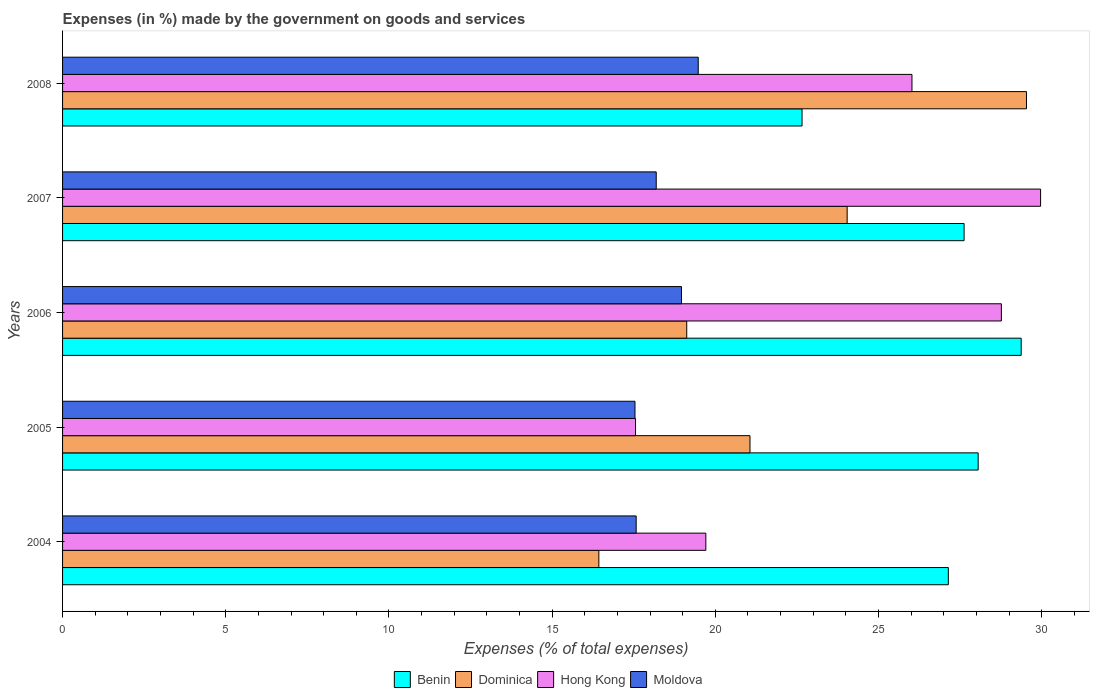How many groups of bars are there?
Keep it short and to the point. 5. Are the number of bars per tick equal to the number of legend labels?
Make the answer very short. Yes. What is the percentage of expenses made by the government on goods and services in Hong Kong in 2007?
Your answer should be compact. 29.97. Across all years, what is the maximum percentage of expenses made by the government on goods and services in Dominica?
Your answer should be compact. 29.53. Across all years, what is the minimum percentage of expenses made by the government on goods and services in Moldova?
Ensure brevity in your answer.  17.54. In which year was the percentage of expenses made by the government on goods and services in Benin minimum?
Keep it short and to the point. 2008. What is the total percentage of expenses made by the government on goods and services in Dominica in the graph?
Offer a very short reply. 110.19. What is the difference between the percentage of expenses made by the government on goods and services in Dominica in 2004 and that in 2005?
Provide a succinct answer. -4.63. What is the difference between the percentage of expenses made by the government on goods and services in Moldova in 2004 and the percentage of expenses made by the government on goods and services in Benin in 2008?
Keep it short and to the point. -5.08. What is the average percentage of expenses made by the government on goods and services in Benin per year?
Keep it short and to the point. 26.97. In the year 2006, what is the difference between the percentage of expenses made by the government on goods and services in Moldova and percentage of expenses made by the government on goods and services in Hong Kong?
Your response must be concise. -9.8. In how many years, is the percentage of expenses made by the government on goods and services in Dominica greater than 15 %?
Your answer should be compact. 5. What is the ratio of the percentage of expenses made by the government on goods and services in Benin in 2006 to that in 2007?
Offer a terse response. 1.06. Is the difference between the percentage of expenses made by the government on goods and services in Moldova in 2005 and 2007 greater than the difference between the percentage of expenses made by the government on goods and services in Hong Kong in 2005 and 2007?
Your response must be concise. Yes. What is the difference between the highest and the second highest percentage of expenses made by the government on goods and services in Benin?
Your answer should be compact. 1.32. What is the difference between the highest and the lowest percentage of expenses made by the government on goods and services in Benin?
Your answer should be very brief. 6.71. In how many years, is the percentage of expenses made by the government on goods and services in Hong Kong greater than the average percentage of expenses made by the government on goods and services in Hong Kong taken over all years?
Provide a short and direct response. 3. What does the 2nd bar from the top in 2007 represents?
Keep it short and to the point. Hong Kong. What does the 3rd bar from the bottom in 2004 represents?
Offer a very short reply. Hong Kong. Are all the bars in the graph horizontal?
Keep it short and to the point. Yes. Are the values on the major ticks of X-axis written in scientific E-notation?
Offer a very short reply. No. Does the graph contain any zero values?
Offer a very short reply. No. How many legend labels are there?
Your answer should be very brief. 4. What is the title of the graph?
Make the answer very short. Expenses (in %) made by the government on goods and services. Does "Bangladesh" appear as one of the legend labels in the graph?
Your answer should be compact. No. What is the label or title of the X-axis?
Keep it short and to the point. Expenses (% of total expenses). What is the Expenses (% of total expenses) of Benin in 2004?
Make the answer very short. 27.14. What is the Expenses (% of total expenses) in Dominica in 2004?
Your response must be concise. 16.43. What is the Expenses (% of total expenses) of Hong Kong in 2004?
Provide a succinct answer. 19.71. What is the Expenses (% of total expenses) of Moldova in 2004?
Your answer should be compact. 17.57. What is the Expenses (% of total expenses) of Benin in 2005?
Offer a very short reply. 28.05. What is the Expenses (% of total expenses) in Dominica in 2005?
Give a very brief answer. 21.06. What is the Expenses (% of total expenses) in Hong Kong in 2005?
Keep it short and to the point. 17.56. What is the Expenses (% of total expenses) in Moldova in 2005?
Make the answer very short. 17.54. What is the Expenses (% of total expenses) of Benin in 2006?
Make the answer very short. 29.37. What is the Expenses (% of total expenses) in Dominica in 2006?
Provide a short and direct response. 19.12. What is the Expenses (% of total expenses) in Hong Kong in 2006?
Provide a succinct answer. 28.76. What is the Expenses (% of total expenses) in Moldova in 2006?
Offer a terse response. 18.96. What is the Expenses (% of total expenses) in Benin in 2007?
Your answer should be compact. 27.62. What is the Expenses (% of total expenses) of Dominica in 2007?
Offer a terse response. 24.04. What is the Expenses (% of total expenses) of Hong Kong in 2007?
Your response must be concise. 29.97. What is the Expenses (% of total expenses) of Moldova in 2007?
Ensure brevity in your answer.  18.19. What is the Expenses (% of total expenses) of Benin in 2008?
Offer a very short reply. 22.66. What is the Expenses (% of total expenses) in Dominica in 2008?
Your answer should be compact. 29.53. What is the Expenses (% of total expenses) in Hong Kong in 2008?
Make the answer very short. 26.02. What is the Expenses (% of total expenses) of Moldova in 2008?
Offer a very short reply. 19.48. Across all years, what is the maximum Expenses (% of total expenses) of Benin?
Offer a terse response. 29.37. Across all years, what is the maximum Expenses (% of total expenses) of Dominica?
Offer a terse response. 29.53. Across all years, what is the maximum Expenses (% of total expenses) of Hong Kong?
Keep it short and to the point. 29.97. Across all years, what is the maximum Expenses (% of total expenses) in Moldova?
Keep it short and to the point. 19.48. Across all years, what is the minimum Expenses (% of total expenses) in Benin?
Offer a terse response. 22.66. Across all years, what is the minimum Expenses (% of total expenses) in Dominica?
Offer a terse response. 16.43. Across all years, what is the minimum Expenses (% of total expenses) of Hong Kong?
Ensure brevity in your answer.  17.56. Across all years, what is the minimum Expenses (% of total expenses) of Moldova?
Your answer should be very brief. 17.54. What is the total Expenses (% of total expenses) of Benin in the graph?
Your response must be concise. 134.84. What is the total Expenses (% of total expenses) of Dominica in the graph?
Give a very brief answer. 110.19. What is the total Expenses (% of total expenses) of Hong Kong in the graph?
Keep it short and to the point. 122.02. What is the total Expenses (% of total expenses) in Moldova in the graph?
Make the answer very short. 91.74. What is the difference between the Expenses (% of total expenses) of Benin in 2004 and that in 2005?
Your answer should be compact. -0.91. What is the difference between the Expenses (% of total expenses) of Dominica in 2004 and that in 2005?
Give a very brief answer. -4.63. What is the difference between the Expenses (% of total expenses) of Hong Kong in 2004 and that in 2005?
Your answer should be very brief. 2.15. What is the difference between the Expenses (% of total expenses) in Moldova in 2004 and that in 2005?
Ensure brevity in your answer.  0.04. What is the difference between the Expenses (% of total expenses) in Benin in 2004 and that in 2006?
Your answer should be compact. -2.23. What is the difference between the Expenses (% of total expenses) of Dominica in 2004 and that in 2006?
Make the answer very short. -2.69. What is the difference between the Expenses (% of total expenses) of Hong Kong in 2004 and that in 2006?
Your response must be concise. -9.05. What is the difference between the Expenses (% of total expenses) in Moldova in 2004 and that in 2006?
Provide a short and direct response. -1.39. What is the difference between the Expenses (% of total expenses) of Benin in 2004 and that in 2007?
Give a very brief answer. -0.48. What is the difference between the Expenses (% of total expenses) of Dominica in 2004 and that in 2007?
Offer a terse response. -7.61. What is the difference between the Expenses (% of total expenses) in Hong Kong in 2004 and that in 2007?
Your answer should be very brief. -10.26. What is the difference between the Expenses (% of total expenses) of Moldova in 2004 and that in 2007?
Your answer should be compact. -0.61. What is the difference between the Expenses (% of total expenses) of Benin in 2004 and that in 2008?
Your answer should be very brief. 4.48. What is the difference between the Expenses (% of total expenses) in Dominica in 2004 and that in 2008?
Offer a very short reply. -13.1. What is the difference between the Expenses (% of total expenses) in Hong Kong in 2004 and that in 2008?
Your answer should be compact. -6.32. What is the difference between the Expenses (% of total expenses) in Moldova in 2004 and that in 2008?
Keep it short and to the point. -1.9. What is the difference between the Expenses (% of total expenses) of Benin in 2005 and that in 2006?
Provide a short and direct response. -1.32. What is the difference between the Expenses (% of total expenses) in Dominica in 2005 and that in 2006?
Your answer should be compact. 1.94. What is the difference between the Expenses (% of total expenses) of Hong Kong in 2005 and that in 2006?
Give a very brief answer. -11.21. What is the difference between the Expenses (% of total expenses) of Moldova in 2005 and that in 2006?
Keep it short and to the point. -1.42. What is the difference between the Expenses (% of total expenses) in Benin in 2005 and that in 2007?
Offer a terse response. 0.43. What is the difference between the Expenses (% of total expenses) of Dominica in 2005 and that in 2007?
Your answer should be compact. -2.98. What is the difference between the Expenses (% of total expenses) of Hong Kong in 2005 and that in 2007?
Your response must be concise. -12.41. What is the difference between the Expenses (% of total expenses) of Moldova in 2005 and that in 2007?
Ensure brevity in your answer.  -0.65. What is the difference between the Expenses (% of total expenses) of Benin in 2005 and that in 2008?
Ensure brevity in your answer.  5.4. What is the difference between the Expenses (% of total expenses) of Dominica in 2005 and that in 2008?
Keep it short and to the point. -8.47. What is the difference between the Expenses (% of total expenses) of Hong Kong in 2005 and that in 2008?
Offer a terse response. -8.47. What is the difference between the Expenses (% of total expenses) in Moldova in 2005 and that in 2008?
Your answer should be very brief. -1.94. What is the difference between the Expenses (% of total expenses) in Benin in 2006 and that in 2007?
Make the answer very short. 1.75. What is the difference between the Expenses (% of total expenses) of Dominica in 2006 and that in 2007?
Your answer should be compact. -4.92. What is the difference between the Expenses (% of total expenses) in Hong Kong in 2006 and that in 2007?
Keep it short and to the point. -1.2. What is the difference between the Expenses (% of total expenses) of Moldova in 2006 and that in 2007?
Provide a short and direct response. 0.77. What is the difference between the Expenses (% of total expenses) in Benin in 2006 and that in 2008?
Ensure brevity in your answer.  6.71. What is the difference between the Expenses (% of total expenses) in Dominica in 2006 and that in 2008?
Your answer should be very brief. -10.41. What is the difference between the Expenses (% of total expenses) of Hong Kong in 2006 and that in 2008?
Make the answer very short. 2.74. What is the difference between the Expenses (% of total expenses) of Moldova in 2006 and that in 2008?
Keep it short and to the point. -0.51. What is the difference between the Expenses (% of total expenses) of Benin in 2007 and that in 2008?
Ensure brevity in your answer.  4.97. What is the difference between the Expenses (% of total expenses) of Dominica in 2007 and that in 2008?
Ensure brevity in your answer.  -5.49. What is the difference between the Expenses (% of total expenses) in Hong Kong in 2007 and that in 2008?
Offer a very short reply. 3.94. What is the difference between the Expenses (% of total expenses) of Moldova in 2007 and that in 2008?
Give a very brief answer. -1.29. What is the difference between the Expenses (% of total expenses) in Benin in 2004 and the Expenses (% of total expenses) in Dominica in 2005?
Give a very brief answer. 6.08. What is the difference between the Expenses (% of total expenses) in Benin in 2004 and the Expenses (% of total expenses) in Hong Kong in 2005?
Your response must be concise. 9.58. What is the difference between the Expenses (% of total expenses) of Benin in 2004 and the Expenses (% of total expenses) of Moldova in 2005?
Offer a terse response. 9.6. What is the difference between the Expenses (% of total expenses) in Dominica in 2004 and the Expenses (% of total expenses) in Hong Kong in 2005?
Your answer should be very brief. -1.12. What is the difference between the Expenses (% of total expenses) in Dominica in 2004 and the Expenses (% of total expenses) in Moldova in 2005?
Your response must be concise. -1.11. What is the difference between the Expenses (% of total expenses) in Hong Kong in 2004 and the Expenses (% of total expenses) in Moldova in 2005?
Provide a short and direct response. 2.17. What is the difference between the Expenses (% of total expenses) of Benin in 2004 and the Expenses (% of total expenses) of Dominica in 2006?
Make the answer very short. 8.02. What is the difference between the Expenses (% of total expenses) in Benin in 2004 and the Expenses (% of total expenses) in Hong Kong in 2006?
Ensure brevity in your answer.  -1.62. What is the difference between the Expenses (% of total expenses) of Benin in 2004 and the Expenses (% of total expenses) of Moldova in 2006?
Keep it short and to the point. 8.18. What is the difference between the Expenses (% of total expenses) in Dominica in 2004 and the Expenses (% of total expenses) in Hong Kong in 2006?
Give a very brief answer. -12.33. What is the difference between the Expenses (% of total expenses) in Dominica in 2004 and the Expenses (% of total expenses) in Moldova in 2006?
Offer a terse response. -2.53. What is the difference between the Expenses (% of total expenses) of Hong Kong in 2004 and the Expenses (% of total expenses) of Moldova in 2006?
Give a very brief answer. 0.75. What is the difference between the Expenses (% of total expenses) in Benin in 2004 and the Expenses (% of total expenses) in Dominica in 2007?
Provide a succinct answer. 3.1. What is the difference between the Expenses (% of total expenses) of Benin in 2004 and the Expenses (% of total expenses) of Hong Kong in 2007?
Ensure brevity in your answer.  -2.83. What is the difference between the Expenses (% of total expenses) in Benin in 2004 and the Expenses (% of total expenses) in Moldova in 2007?
Provide a short and direct response. 8.95. What is the difference between the Expenses (% of total expenses) in Dominica in 2004 and the Expenses (% of total expenses) in Hong Kong in 2007?
Your answer should be very brief. -13.53. What is the difference between the Expenses (% of total expenses) of Dominica in 2004 and the Expenses (% of total expenses) of Moldova in 2007?
Give a very brief answer. -1.76. What is the difference between the Expenses (% of total expenses) of Hong Kong in 2004 and the Expenses (% of total expenses) of Moldova in 2007?
Your answer should be very brief. 1.52. What is the difference between the Expenses (% of total expenses) of Benin in 2004 and the Expenses (% of total expenses) of Dominica in 2008?
Give a very brief answer. -2.39. What is the difference between the Expenses (% of total expenses) in Benin in 2004 and the Expenses (% of total expenses) in Hong Kong in 2008?
Provide a short and direct response. 1.11. What is the difference between the Expenses (% of total expenses) in Benin in 2004 and the Expenses (% of total expenses) in Moldova in 2008?
Your response must be concise. 7.66. What is the difference between the Expenses (% of total expenses) in Dominica in 2004 and the Expenses (% of total expenses) in Hong Kong in 2008?
Your response must be concise. -9.59. What is the difference between the Expenses (% of total expenses) of Dominica in 2004 and the Expenses (% of total expenses) of Moldova in 2008?
Provide a succinct answer. -3.05. What is the difference between the Expenses (% of total expenses) of Hong Kong in 2004 and the Expenses (% of total expenses) of Moldova in 2008?
Ensure brevity in your answer.  0.23. What is the difference between the Expenses (% of total expenses) of Benin in 2005 and the Expenses (% of total expenses) of Dominica in 2006?
Ensure brevity in your answer.  8.93. What is the difference between the Expenses (% of total expenses) of Benin in 2005 and the Expenses (% of total expenses) of Hong Kong in 2006?
Ensure brevity in your answer.  -0.71. What is the difference between the Expenses (% of total expenses) of Benin in 2005 and the Expenses (% of total expenses) of Moldova in 2006?
Offer a very short reply. 9.09. What is the difference between the Expenses (% of total expenses) of Dominica in 2005 and the Expenses (% of total expenses) of Hong Kong in 2006?
Offer a terse response. -7.7. What is the difference between the Expenses (% of total expenses) in Dominica in 2005 and the Expenses (% of total expenses) in Moldova in 2006?
Make the answer very short. 2.1. What is the difference between the Expenses (% of total expenses) in Hong Kong in 2005 and the Expenses (% of total expenses) in Moldova in 2006?
Ensure brevity in your answer.  -1.41. What is the difference between the Expenses (% of total expenses) of Benin in 2005 and the Expenses (% of total expenses) of Dominica in 2007?
Make the answer very short. 4.01. What is the difference between the Expenses (% of total expenses) of Benin in 2005 and the Expenses (% of total expenses) of Hong Kong in 2007?
Provide a succinct answer. -1.91. What is the difference between the Expenses (% of total expenses) in Benin in 2005 and the Expenses (% of total expenses) in Moldova in 2007?
Give a very brief answer. 9.86. What is the difference between the Expenses (% of total expenses) of Dominica in 2005 and the Expenses (% of total expenses) of Hong Kong in 2007?
Give a very brief answer. -8.9. What is the difference between the Expenses (% of total expenses) in Dominica in 2005 and the Expenses (% of total expenses) in Moldova in 2007?
Offer a very short reply. 2.87. What is the difference between the Expenses (% of total expenses) in Hong Kong in 2005 and the Expenses (% of total expenses) in Moldova in 2007?
Your answer should be very brief. -0.63. What is the difference between the Expenses (% of total expenses) in Benin in 2005 and the Expenses (% of total expenses) in Dominica in 2008?
Offer a terse response. -1.48. What is the difference between the Expenses (% of total expenses) in Benin in 2005 and the Expenses (% of total expenses) in Hong Kong in 2008?
Make the answer very short. 2.03. What is the difference between the Expenses (% of total expenses) in Benin in 2005 and the Expenses (% of total expenses) in Moldova in 2008?
Provide a succinct answer. 8.58. What is the difference between the Expenses (% of total expenses) of Dominica in 2005 and the Expenses (% of total expenses) of Hong Kong in 2008?
Your answer should be compact. -4.96. What is the difference between the Expenses (% of total expenses) in Dominica in 2005 and the Expenses (% of total expenses) in Moldova in 2008?
Give a very brief answer. 1.59. What is the difference between the Expenses (% of total expenses) of Hong Kong in 2005 and the Expenses (% of total expenses) of Moldova in 2008?
Your answer should be compact. -1.92. What is the difference between the Expenses (% of total expenses) in Benin in 2006 and the Expenses (% of total expenses) in Dominica in 2007?
Make the answer very short. 5.33. What is the difference between the Expenses (% of total expenses) of Benin in 2006 and the Expenses (% of total expenses) of Hong Kong in 2007?
Offer a very short reply. -0.59. What is the difference between the Expenses (% of total expenses) in Benin in 2006 and the Expenses (% of total expenses) in Moldova in 2007?
Your answer should be very brief. 11.18. What is the difference between the Expenses (% of total expenses) in Dominica in 2006 and the Expenses (% of total expenses) in Hong Kong in 2007?
Your answer should be compact. -10.84. What is the difference between the Expenses (% of total expenses) in Dominica in 2006 and the Expenses (% of total expenses) in Moldova in 2007?
Ensure brevity in your answer.  0.93. What is the difference between the Expenses (% of total expenses) in Hong Kong in 2006 and the Expenses (% of total expenses) in Moldova in 2007?
Your answer should be compact. 10.57. What is the difference between the Expenses (% of total expenses) of Benin in 2006 and the Expenses (% of total expenses) of Dominica in 2008?
Offer a very short reply. -0.16. What is the difference between the Expenses (% of total expenses) in Benin in 2006 and the Expenses (% of total expenses) in Hong Kong in 2008?
Keep it short and to the point. 3.35. What is the difference between the Expenses (% of total expenses) in Benin in 2006 and the Expenses (% of total expenses) in Moldova in 2008?
Your answer should be compact. 9.89. What is the difference between the Expenses (% of total expenses) in Dominica in 2006 and the Expenses (% of total expenses) in Hong Kong in 2008?
Ensure brevity in your answer.  -6.9. What is the difference between the Expenses (% of total expenses) in Dominica in 2006 and the Expenses (% of total expenses) in Moldova in 2008?
Offer a very short reply. -0.35. What is the difference between the Expenses (% of total expenses) of Hong Kong in 2006 and the Expenses (% of total expenses) of Moldova in 2008?
Your answer should be compact. 9.29. What is the difference between the Expenses (% of total expenses) of Benin in 2007 and the Expenses (% of total expenses) of Dominica in 2008?
Your answer should be very brief. -1.91. What is the difference between the Expenses (% of total expenses) in Benin in 2007 and the Expenses (% of total expenses) in Hong Kong in 2008?
Give a very brief answer. 1.6. What is the difference between the Expenses (% of total expenses) in Benin in 2007 and the Expenses (% of total expenses) in Moldova in 2008?
Keep it short and to the point. 8.15. What is the difference between the Expenses (% of total expenses) in Dominica in 2007 and the Expenses (% of total expenses) in Hong Kong in 2008?
Ensure brevity in your answer.  -1.99. What is the difference between the Expenses (% of total expenses) of Dominica in 2007 and the Expenses (% of total expenses) of Moldova in 2008?
Offer a very short reply. 4.56. What is the difference between the Expenses (% of total expenses) of Hong Kong in 2007 and the Expenses (% of total expenses) of Moldova in 2008?
Keep it short and to the point. 10.49. What is the average Expenses (% of total expenses) in Benin per year?
Your answer should be compact. 26.97. What is the average Expenses (% of total expenses) of Dominica per year?
Make the answer very short. 22.04. What is the average Expenses (% of total expenses) of Hong Kong per year?
Provide a short and direct response. 24.4. What is the average Expenses (% of total expenses) of Moldova per year?
Provide a succinct answer. 18.35. In the year 2004, what is the difference between the Expenses (% of total expenses) in Benin and Expenses (% of total expenses) in Dominica?
Your answer should be very brief. 10.71. In the year 2004, what is the difference between the Expenses (% of total expenses) in Benin and Expenses (% of total expenses) in Hong Kong?
Ensure brevity in your answer.  7.43. In the year 2004, what is the difference between the Expenses (% of total expenses) of Benin and Expenses (% of total expenses) of Moldova?
Offer a very short reply. 9.56. In the year 2004, what is the difference between the Expenses (% of total expenses) of Dominica and Expenses (% of total expenses) of Hong Kong?
Give a very brief answer. -3.28. In the year 2004, what is the difference between the Expenses (% of total expenses) in Dominica and Expenses (% of total expenses) in Moldova?
Your response must be concise. -1.14. In the year 2004, what is the difference between the Expenses (% of total expenses) in Hong Kong and Expenses (% of total expenses) in Moldova?
Give a very brief answer. 2.13. In the year 2005, what is the difference between the Expenses (% of total expenses) in Benin and Expenses (% of total expenses) in Dominica?
Your answer should be very brief. 6.99. In the year 2005, what is the difference between the Expenses (% of total expenses) in Benin and Expenses (% of total expenses) in Hong Kong?
Offer a terse response. 10.5. In the year 2005, what is the difference between the Expenses (% of total expenses) in Benin and Expenses (% of total expenses) in Moldova?
Offer a very short reply. 10.51. In the year 2005, what is the difference between the Expenses (% of total expenses) of Dominica and Expenses (% of total expenses) of Hong Kong?
Ensure brevity in your answer.  3.51. In the year 2005, what is the difference between the Expenses (% of total expenses) in Dominica and Expenses (% of total expenses) in Moldova?
Your answer should be very brief. 3.52. In the year 2005, what is the difference between the Expenses (% of total expenses) in Hong Kong and Expenses (% of total expenses) in Moldova?
Make the answer very short. 0.02. In the year 2006, what is the difference between the Expenses (% of total expenses) of Benin and Expenses (% of total expenses) of Dominica?
Provide a succinct answer. 10.25. In the year 2006, what is the difference between the Expenses (% of total expenses) in Benin and Expenses (% of total expenses) in Hong Kong?
Provide a short and direct response. 0.61. In the year 2006, what is the difference between the Expenses (% of total expenses) in Benin and Expenses (% of total expenses) in Moldova?
Provide a succinct answer. 10.41. In the year 2006, what is the difference between the Expenses (% of total expenses) in Dominica and Expenses (% of total expenses) in Hong Kong?
Ensure brevity in your answer.  -9.64. In the year 2006, what is the difference between the Expenses (% of total expenses) of Dominica and Expenses (% of total expenses) of Moldova?
Give a very brief answer. 0.16. In the year 2006, what is the difference between the Expenses (% of total expenses) in Hong Kong and Expenses (% of total expenses) in Moldova?
Keep it short and to the point. 9.8. In the year 2007, what is the difference between the Expenses (% of total expenses) in Benin and Expenses (% of total expenses) in Dominica?
Make the answer very short. 3.58. In the year 2007, what is the difference between the Expenses (% of total expenses) of Benin and Expenses (% of total expenses) of Hong Kong?
Offer a very short reply. -2.34. In the year 2007, what is the difference between the Expenses (% of total expenses) of Benin and Expenses (% of total expenses) of Moldova?
Keep it short and to the point. 9.43. In the year 2007, what is the difference between the Expenses (% of total expenses) of Dominica and Expenses (% of total expenses) of Hong Kong?
Your answer should be very brief. -5.93. In the year 2007, what is the difference between the Expenses (% of total expenses) in Dominica and Expenses (% of total expenses) in Moldova?
Your response must be concise. 5.85. In the year 2007, what is the difference between the Expenses (% of total expenses) of Hong Kong and Expenses (% of total expenses) of Moldova?
Your answer should be compact. 11.78. In the year 2008, what is the difference between the Expenses (% of total expenses) in Benin and Expenses (% of total expenses) in Dominica?
Make the answer very short. -6.88. In the year 2008, what is the difference between the Expenses (% of total expenses) of Benin and Expenses (% of total expenses) of Hong Kong?
Provide a short and direct response. -3.37. In the year 2008, what is the difference between the Expenses (% of total expenses) in Benin and Expenses (% of total expenses) in Moldova?
Provide a short and direct response. 3.18. In the year 2008, what is the difference between the Expenses (% of total expenses) of Dominica and Expenses (% of total expenses) of Hong Kong?
Keep it short and to the point. 3.51. In the year 2008, what is the difference between the Expenses (% of total expenses) in Dominica and Expenses (% of total expenses) in Moldova?
Provide a succinct answer. 10.06. In the year 2008, what is the difference between the Expenses (% of total expenses) in Hong Kong and Expenses (% of total expenses) in Moldova?
Give a very brief answer. 6.55. What is the ratio of the Expenses (% of total expenses) of Benin in 2004 to that in 2005?
Offer a very short reply. 0.97. What is the ratio of the Expenses (% of total expenses) of Dominica in 2004 to that in 2005?
Your response must be concise. 0.78. What is the ratio of the Expenses (% of total expenses) of Hong Kong in 2004 to that in 2005?
Your answer should be compact. 1.12. What is the ratio of the Expenses (% of total expenses) of Benin in 2004 to that in 2006?
Provide a short and direct response. 0.92. What is the ratio of the Expenses (% of total expenses) in Dominica in 2004 to that in 2006?
Give a very brief answer. 0.86. What is the ratio of the Expenses (% of total expenses) of Hong Kong in 2004 to that in 2006?
Provide a short and direct response. 0.69. What is the ratio of the Expenses (% of total expenses) in Moldova in 2004 to that in 2006?
Make the answer very short. 0.93. What is the ratio of the Expenses (% of total expenses) of Benin in 2004 to that in 2007?
Your response must be concise. 0.98. What is the ratio of the Expenses (% of total expenses) in Dominica in 2004 to that in 2007?
Your response must be concise. 0.68. What is the ratio of the Expenses (% of total expenses) of Hong Kong in 2004 to that in 2007?
Your answer should be compact. 0.66. What is the ratio of the Expenses (% of total expenses) in Moldova in 2004 to that in 2007?
Offer a very short reply. 0.97. What is the ratio of the Expenses (% of total expenses) in Benin in 2004 to that in 2008?
Make the answer very short. 1.2. What is the ratio of the Expenses (% of total expenses) of Dominica in 2004 to that in 2008?
Provide a short and direct response. 0.56. What is the ratio of the Expenses (% of total expenses) in Hong Kong in 2004 to that in 2008?
Your response must be concise. 0.76. What is the ratio of the Expenses (% of total expenses) in Moldova in 2004 to that in 2008?
Ensure brevity in your answer.  0.9. What is the ratio of the Expenses (% of total expenses) of Benin in 2005 to that in 2006?
Make the answer very short. 0.96. What is the ratio of the Expenses (% of total expenses) of Dominica in 2005 to that in 2006?
Offer a very short reply. 1.1. What is the ratio of the Expenses (% of total expenses) in Hong Kong in 2005 to that in 2006?
Your response must be concise. 0.61. What is the ratio of the Expenses (% of total expenses) in Moldova in 2005 to that in 2006?
Your answer should be compact. 0.92. What is the ratio of the Expenses (% of total expenses) of Benin in 2005 to that in 2007?
Keep it short and to the point. 1.02. What is the ratio of the Expenses (% of total expenses) in Dominica in 2005 to that in 2007?
Your answer should be very brief. 0.88. What is the ratio of the Expenses (% of total expenses) of Hong Kong in 2005 to that in 2007?
Ensure brevity in your answer.  0.59. What is the ratio of the Expenses (% of total expenses) in Moldova in 2005 to that in 2007?
Your answer should be very brief. 0.96. What is the ratio of the Expenses (% of total expenses) of Benin in 2005 to that in 2008?
Offer a very short reply. 1.24. What is the ratio of the Expenses (% of total expenses) of Dominica in 2005 to that in 2008?
Your response must be concise. 0.71. What is the ratio of the Expenses (% of total expenses) in Hong Kong in 2005 to that in 2008?
Your answer should be very brief. 0.67. What is the ratio of the Expenses (% of total expenses) in Moldova in 2005 to that in 2008?
Provide a short and direct response. 0.9. What is the ratio of the Expenses (% of total expenses) in Benin in 2006 to that in 2007?
Provide a short and direct response. 1.06. What is the ratio of the Expenses (% of total expenses) of Dominica in 2006 to that in 2007?
Offer a very short reply. 0.8. What is the ratio of the Expenses (% of total expenses) in Hong Kong in 2006 to that in 2007?
Ensure brevity in your answer.  0.96. What is the ratio of the Expenses (% of total expenses) of Moldova in 2006 to that in 2007?
Offer a terse response. 1.04. What is the ratio of the Expenses (% of total expenses) in Benin in 2006 to that in 2008?
Offer a very short reply. 1.3. What is the ratio of the Expenses (% of total expenses) in Dominica in 2006 to that in 2008?
Offer a very short reply. 0.65. What is the ratio of the Expenses (% of total expenses) of Hong Kong in 2006 to that in 2008?
Offer a very short reply. 1.11. What is the ratio of the Expenses (% of total expenses) in Moldova in 2006 to that in 2008?
Make the answer very short. 0.97. What is the ratio of the Expenses (% of total expenses) in Benin in 2007 to that in 2008?
Your response must be concise. 1.22. What is the ratio of the Expenses (% of total expenses) of Dominica in 2007 to that in 2008?
Make the answer very short. 0.81. What is the ratio of the Expenses (% of total expenses) of Hong Kong in 2007 to that in 2008?
Offer a terse response. 1.15. What is the ratio of the Expenses (% of total expenses) in Moldova in 2007 to that in 2008?
Give a very brief answer. 0.93. What is the difference between the highest and the second highest Expenses (% of total expenses) in Benin?
Your answer should be compact. 1.32. What is the difference between the highest and the second highest Expenses (% of total expenses) of Dominica?
Your answer should be compact. 5.49. What is the difference between the highest and the second highest Expenses (% of total expenses) of Hong Kong?
Ensure brevity in your answer.  1.2. What is the difference between the highest and the second highest Expenses (% of total expenses) in Moldova?
Your answer should be compact. 0.51. What is the difference between the highest and the lowest Expenses (% of total expenses) in Benin?
Offer a very short reply. 6.71. What is the difference between the highest and the lowest Expenses (% of total expenses) in Dominica?
Keep it short and to the point. 13.1. What is the difference between the highest and the lowest Expenses (% of total expenses) in Hong Kong?
Your answer should be very brief. 12.41. What is the difference between the highest and the lowest Expenses (% of total expenses) in Moldova?
Your answer should be compact. 1.94. 